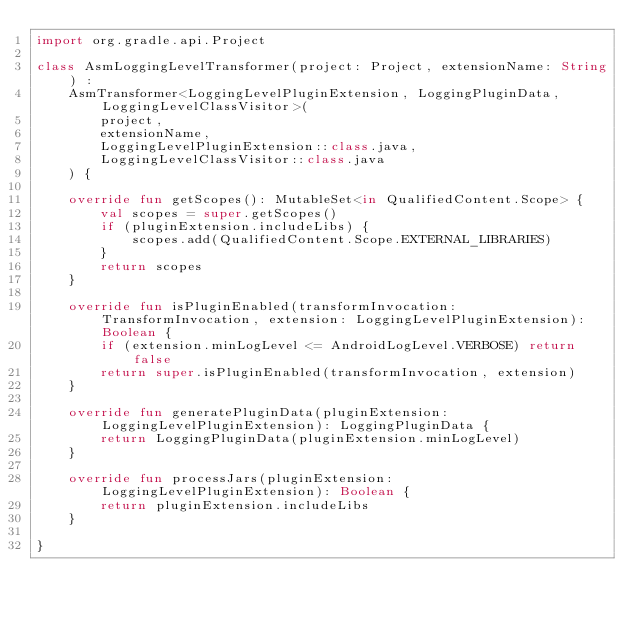Convert code to text. <code><loc_0><loc_0><loc_500><loc_500><_Kotlin_>import org.gradle.api.Project

class AsmLoggingLevelTransformer(project: Project, extensionName: String) :
    AsmTransformer<LoggingLevelPluginExtension, LoggingPluginData, LoggingLevelClassVisitor>(
        project,
        extensionName,
        LoggingLevelPluginExtension::class.java,
        LoggingLevelClassVisitor::class.java
    ) {

    override fun getScopes(): MutableSet<in QualifiedContent.Scope> {
        val scopes = super.getScopes()
        if (pluginExtension.includeLibs) {
            scopes.add(QualifiedContent.Scope.EXTERNAL_LIBRARIES)
        }
        return scopes
    }

    override fun isPluginEnabled(transformInvocation: TransformInvocation, extension: LoggingLevelPluginExtension): Boolean {
        if (extension.minLogLevel <= AndroidLogLevel.VERBOSE) return false
        return super.isPluginEnabled(transformInvocation, extension)
    }

    override fun generatePluginData(pluginExtension: LoggingLevelPluginExtension): LoggingPluginData {
        return LoggingPluginData(pluginExtension.minLogLevel)
    }

    override fun processJars(pluginExtension: LoggingLevelPluginExtension): Boolean {
        return pluginExtension.includeLibs
    }

}
</code> 